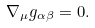<formula> <loc_0><loc_0><loc_500><loc_500>\nabla _ { \mu } g _ { \alpha \beta } = 0 .</formula> 